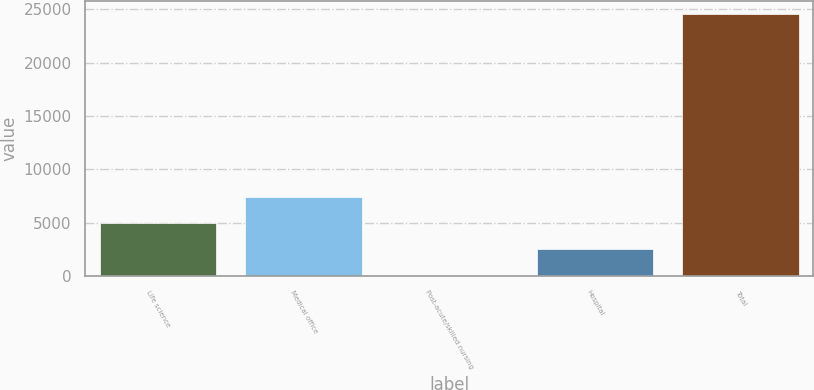<chart> <loc_0><loc_0><loc_500><loc_500><bar_chart><fcel>Life science<fcel>Medical office<fcel>Post-acute/skilled nursing<fcel>Hospital<fcel>Total<nl><fcel>4966.4<fcel>7417.1<fcel>65<fcel>2515.7<fcel>24572<nl></chart> 